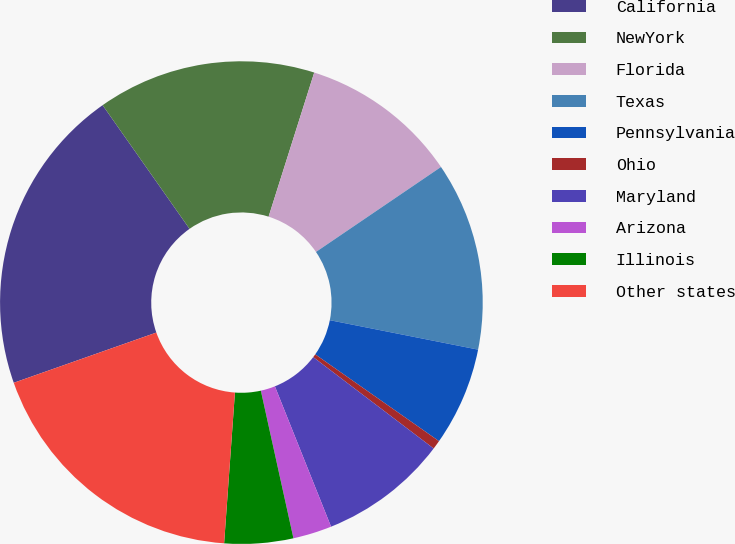<chart> <loc_0><loc_0><loc_500><loc_500><pie_chart><fcel>California<fcel>NewYork<fcel>Florida<fcel>Texas<fcel>Pennsylvania<fcel>Ohio<fcel>Maryland<fcel>Arizona<fcel>Illinois<fcel>Other states<nl><fcel>20.64%<fcel>14.63%<fcel>10.62%<fcel>12.62%<fcel>6.61%<fcel>0.6%<fcel>8.61%<fcel>2.6%<fcel>4.6%<fcel>18.47%<nl></chart> 